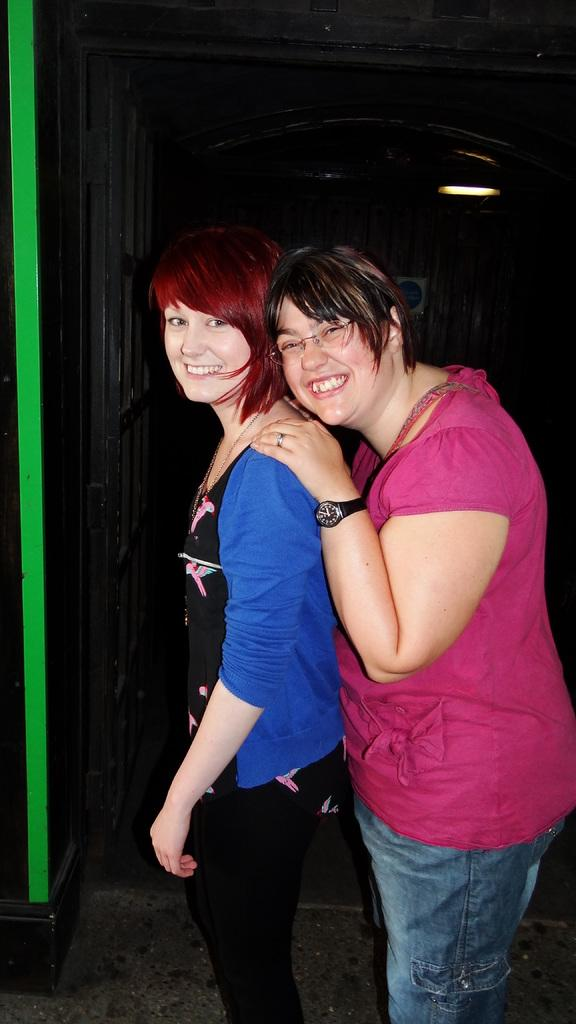How many people are in the image? There are two women in the image. What expressions do the women have? Both women are smiling. Can you describe the background of the image? The background of the image is dark. How many books are on the table in the image? There is no table or books present in the image. What is the lead content of the women's smiles in the image? There is no information about the lead content in the image, and the women's smiles are not related to lead. --- 